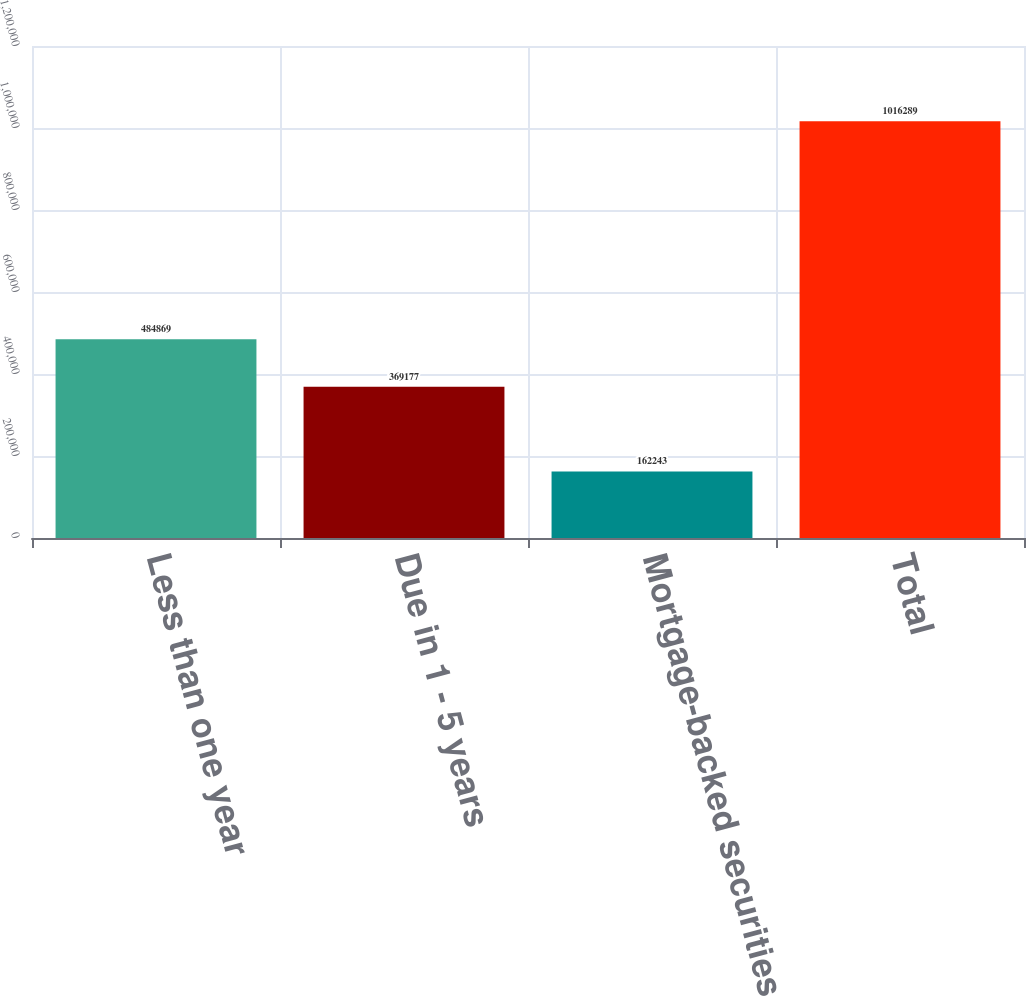<chart> <loc_0><loc_0><loc_500><loc_500><bar_chart><fcel>Less than one year<fcel>Due in 1 - 5 years<fcel>Mortgage-backed securities<fcel>Total<nl><fcel>484869<fcel>369177<fcel>162243<fcel>1.01629e+06<nl></chart> 